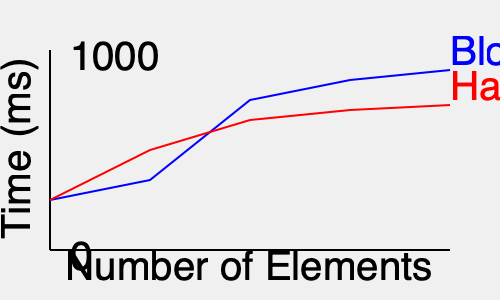Based on the performance graph comparing Guava's BloomFilter and HashSet for element lookup, which data structure exhibits better scalability as the number of elements increases? To determine which data structure exhibits better scalability, we need to analyze the growth patterns of both lines in the graph:

1. The blue line represents BloomFilter's performance.
2. The red line represents HashSet's performance.

Step-by-step analysis:

1. Initial performance: Both structures start at a similar point for a small number of elements.

2. Growth rate:
   - BloomFilter (blue line): Shows a steeper initial increase but flattens out as the number of elements grows.
   - HashSet (red line): Shows a more gradual, consistent increase throughout the range.

3. End-point comparison: At the highest number of elements, BloomFilter's line is lower (faster) than HashSet's line.

4. Slope comparison:
   - BloomFilter's slope decreases as the number of elements increases, indicating improved efficiency at scale.
   - HashSet's slope remains relatively constant, suggesting linear growth in lookup time.

5. Scalability definition: Better scalability is characterized by a sublinear growth in time complexity as the input size increases.

6. Theoretical time complexities:
   - BloomFilter: $O(k)$, where $k$ is the number of hash functions (constant).
   - HashSet: $O(1)$ average case, but can degrade to $O(n)$ in worst-case scenarios.

Given the graph and our understanding of these data structures, BloomFilter demonstrates better scalability. Its performance improves relative to HashSet as the number of elements increases, indicated by the flattening curve and lower position on the graph for larger element counts.
Answer: BloomFilter 